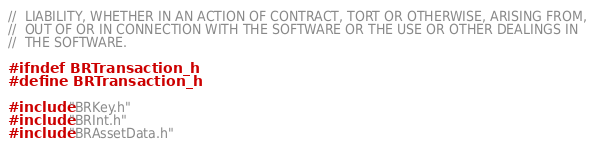Convert code to text. <code><loc_0><loc_0><loc_500><loc_500><_C_>//  LIABILITY, WHETHER IN AN ACTION OF CONTRACT, TORT OR OTHERWISE, ARISING FROM,
//  OUT OF OR IN CONNECTION WITH THE SOFTWARE OR THE USE OR OTHER DEALINGS IN
//  THE SOFTWARE.

#ifndef BRTransaction_h
#define BRTransaction_h

#include "BRKey.h"
#include "BRInt.h"
#include "BRAssetData.h"</code> 